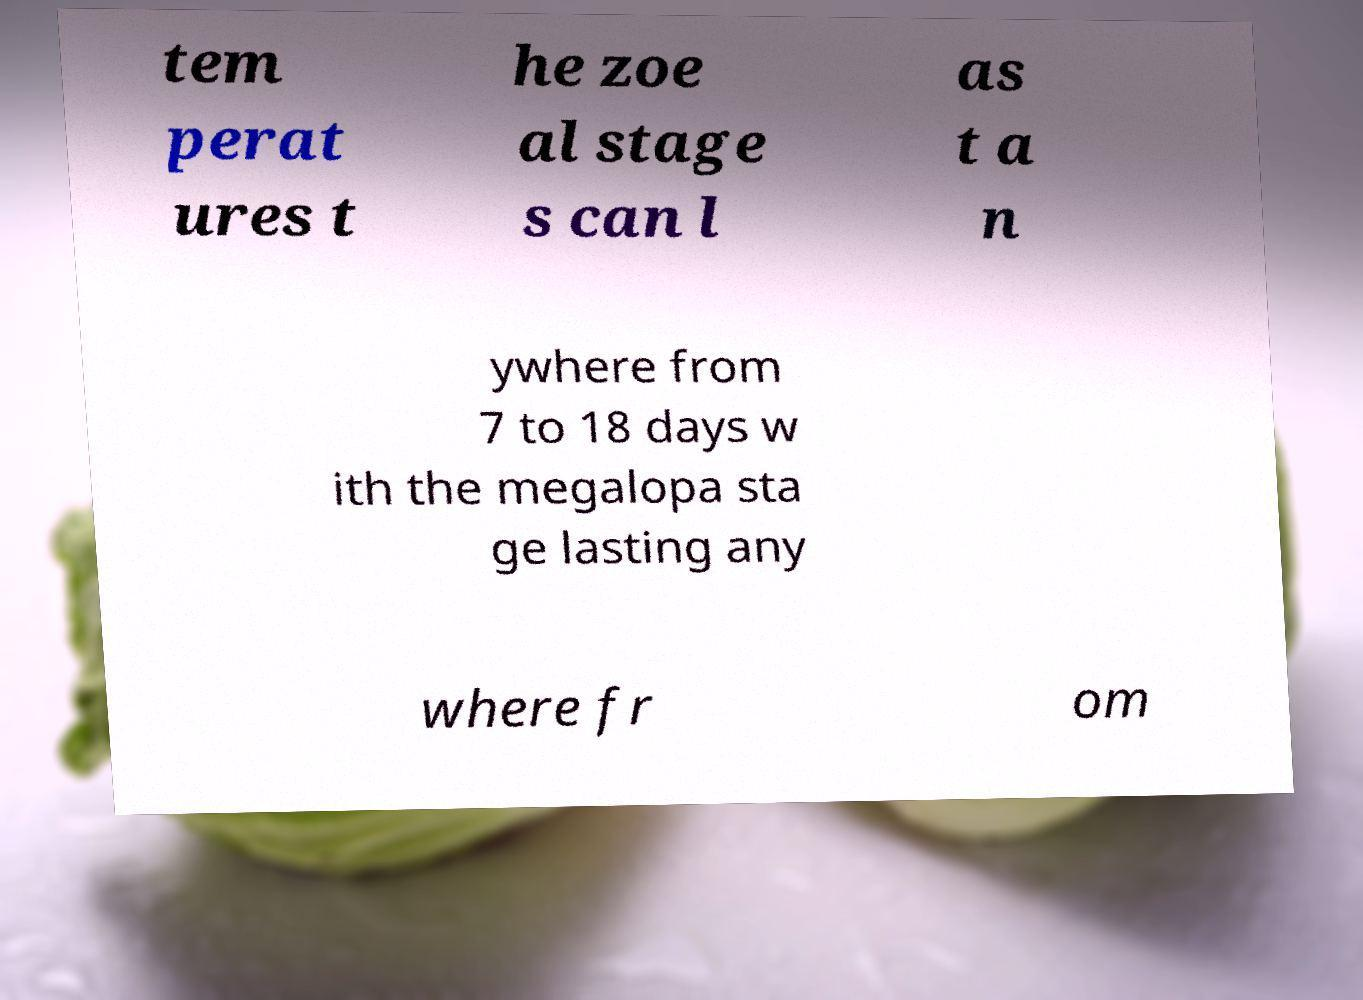Please identify and transcribe the text found in this image. tem perat ures t he zoe al stage s can l as t a n ywhere from 7 to 18 days w ith the megalopa sta ge lasting any where fr om 